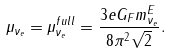<formula> <loc_0><loc_0><loc_500><loc_500>\mu _ { \nu _ { e } } = \mu _ { \nu _ { e } } ^ { f u l l } = \frac { 3 e G _ { F } m _ { \nu _ { e } } ^ { E } } { 8 \pi ^ { 2 } \sqrt { 2 } } .</formula> 